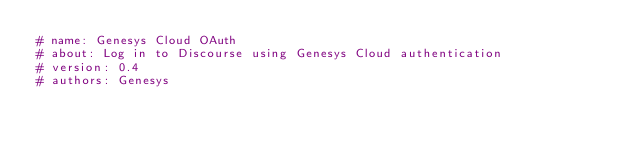Convert code to text. <code><loc_0><loc_0><loc_500><loc_500><_Ruby_># name: Genesys Cloud OAuth
# about: Log in to Discourse using Genesys Cloud authentication
# version: 0.4
# authors: Genesys</code> 